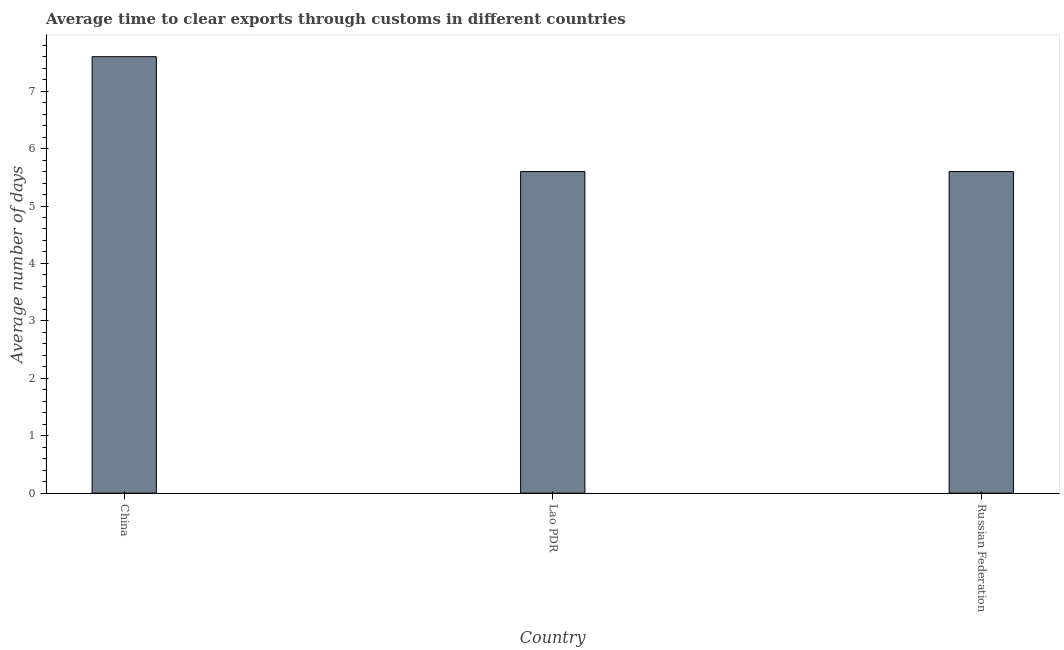Does the graph contain any zero values?
Your response must be concise. No. What is the title of the graph?
Make the answer very short. Average time to clear exports through customs in different countries. What is the label or title of the X-axis?
Your response must be concise. Country. What is the label or title of the Y-axis?
Give a very brief answer. Average number of days. Across all countries, what is the maximum time to clear exports through customs?
Offer a terse response. 7.6. In which country was the time to clear exports through customs minimum?
Keep it short and to the point. Lao PDR. What is the sum of the time to clear exports through customs?
Make the answer very short. 18.8. What is the difference between the time to clear exports through customs in China and Lao PDR?
Keep it short and to the point. 2. What is the average time to clear exports through customs per country?
Your answer should be very brief. 6.27. What is the ratio of the time to clear exports through customs in China to that in Russian Federation?
Your answer should be compact. 1.36. Is the difference between the time to clear exports through customs in China and Russian Federation greater than the difference between any two countries?
Provide a short and direct response. Yes. What is the difference between the highest and the lowest time to clear exports through customs?
Provide a short and direct response. 2. How many bars are there?
Provide a short and direct response. 3. Are all the bars in the graph horizontal?
Give a very brief answer. No. How many countries are there in the graph?
Your answer should be compact. 3. Are the values on the major ticks of Y-axis written in scientific E-notation?
Provide a short and direct response. No. What is the Average number of days in China?
Offer a very short reply. 7.6. What is the Average number of days in Russian Federation?
Ensure brevity in your answer.  5.6. What is the difference between the Average number of days in China and Lao PDR?
Give a very brief answer. 2. What is the difference between the Average number of days in Lao PDR and Russian Federation?
Your answer should be very brief. 0. What is the ratio of the Average number of days in China to that in Lao PDR?
Keep it short and to the point. 1.36. What is the ratio of the Average number of days in China to that in Russian Federation?
Give a very brief answer. 1.36. What is the ratio of the Average number of days in Lao PDR to that in Russian Federation?
Ensure brevity in your answer.  1. 